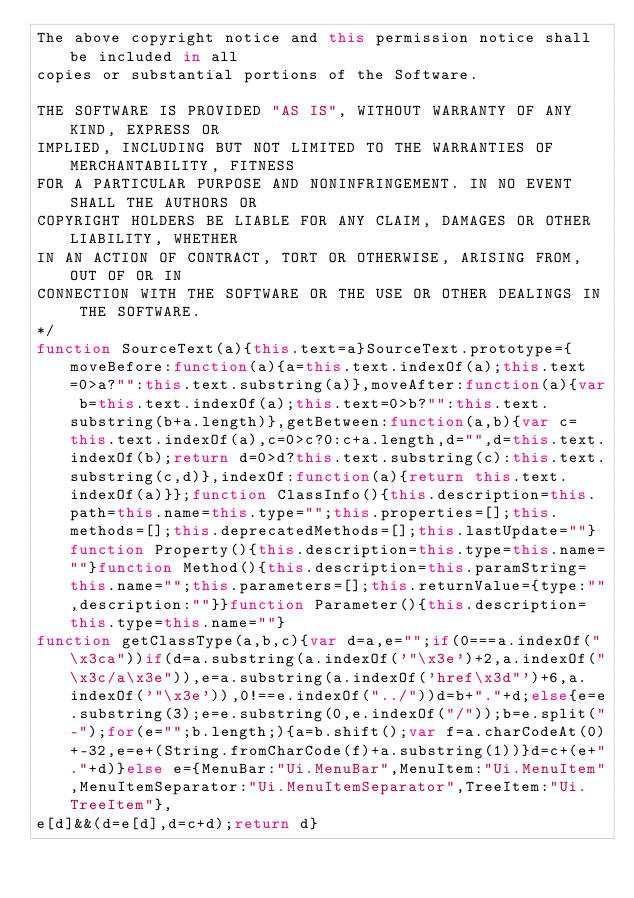<code> <loc_0><loc_0><loc_500><loc_500><_JavaScript_>The above copyright notice and this permission notice shall be included in all
copies or substantial portions of the Software.

THE SOFTWARE IS PROVIDED "AS IS", WITHOUT WARRANTY OF ANY KIND, EXPRESS OR
IMPLIED, INCLUDING BUT NOT LIMITED TO THE WARRANTIES OF MERCHANTABILITY, FITNESS
FOR A PARTICULAR PURPOSE AND NONINFRINGEMENT. IN NO EVENT SHALL THE AUTHORS OR
COPYRIGHT HOLDERS BE LIABLE FOR ANY CLAIM, DAMAGES OR OTHER LIABILITY, WHETHER
IN AN ACTION OF CONTRACT, TORT OR OTHERWISE, ARISING FROM, OUT OF OR IN
CONNECTION WITH THE SOFTWARE OR THE USE OR OTHER DEALINGS IN THE SOFTWARE.
*/
function SourceText(a){this.text=a}SourceText.prototype={moveBefore:function(a){a=this.text.indexOf(a);this.text=0>a?"":this.text.substring(a)},moveAfter:function(a){var b=this.text.indexOf(a);this.text=0>b?"":this.text.substring(b+a.length)},getBetween:function(a,b){var c=this.text.indexOf(a),c=0>c?0:c+a.length,d="",d=this.text.indexOf(b);return d=0>d?this.text.substring(c):this.text.substring(c,d)},indexOf:function(a){return this.text.indexOf(a)}};function ClassInfo(){this.description=this.path=this.name=this.type="";this.properties=[];this.methods=[];this.deprecatedMethods=[];this.lastUpdate=""}function Property(){this.description=this.type=this.name=""}function Method(){this.description=this.paramString=this.name="";this.parameters=[];this.returnValue={type:"",description:""}}function Parameter(){this.description=this.type=this.name=""}
function getClassType(a,b,c){var d=a,e="";if(0===a.indexOf("\x3ca"))if(d=a.substring(a.indexOf('"\x3e')+2,a.indexOf("\x3c/a\x3e")),e=a.substring(a.indexOf('href\x3d"')+6,a.indexOf('"\x3e')),0!==e.indexOf("../"))d=b+"."+d;else{e=e.substring(3);e=e.substring(0,e.indexOf("/"));b=e.split("-");for(e="";b.length;){a=b.shift();var f=a.charCodeAt(0)+-32,e=e+(String.fromCharCode(f)+a.substring(1))}d=c+(e+"."+d)}else e={MenuBar:"Ui.MenuBar",MenuItem:"Ui.MenuItem",MenuItemSeparator:"Ui.MenuItemSeparator",TreeItem:"Ui.TreeItem"},
e[d]&&(d=e[d],d=c+d);return d}</code> 